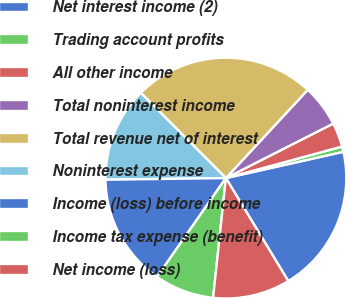<chart> <loc_0><loc_0><loc_500><loc_500><pie_chart><fcel>Net interest income (2)<fcel>Trading account profits<fcel>All other income<fcel>Total noninterest income<fcel>Total revenue net of interest<fcel>Noninterest expense<fcel>Income (loss) before income<fcel>Income tax expense (benefit)<fcel>Net income (loss)<nl><fcel>19.84%<fcel>0.71%<fcel>3.26%<fcel>5.62%<fcel>24.39%<fcel>12.73%<fcel>15.1%<fcel>7.99%<fcel>10.36%<nl></chart> 